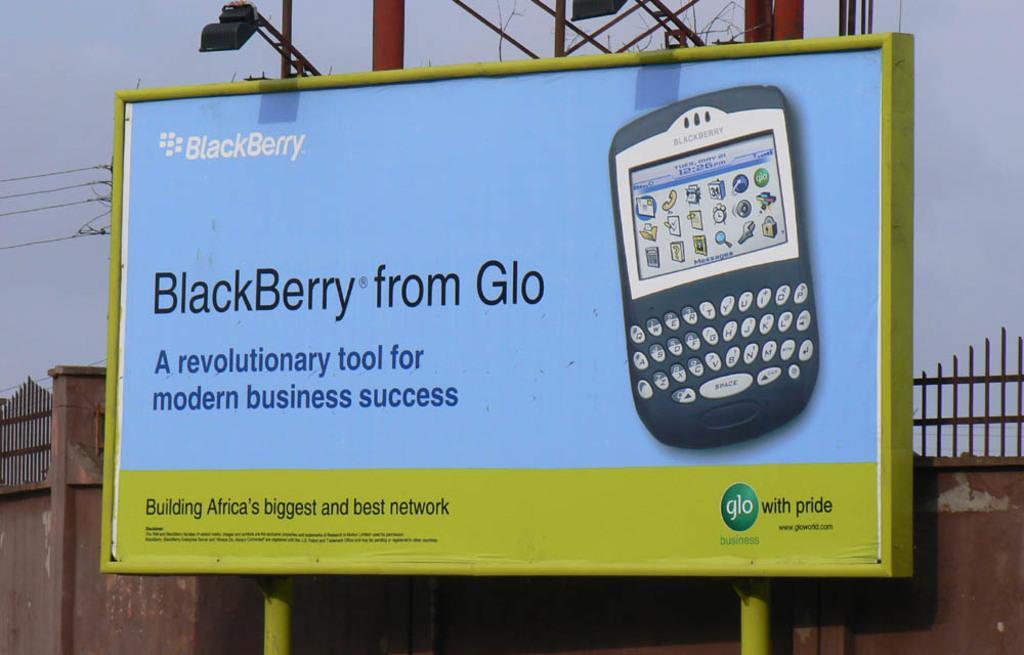In one or two sentences, can you explain what this image depicts? In this picture I can see a hoarding on which we can see some text and image of a mobile, behind we can see a wall with fencing and also we can see some poles with lights. 